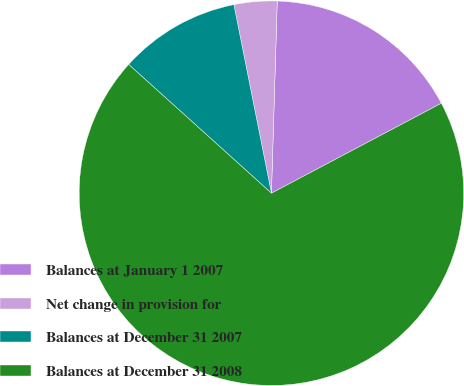<chart> <loc_0><loc_0><loc_500><loc_500><pie_chart><fcel>Balances at January 1 2007<fcel>Net change in provision for<fcel>Balances at December 31 2007<fcel>Balances at December 31 2008<nl><fcel>16.77%<fcel>3.61%<fcel>10.19%<fcel>69.43%<nl></chart> 